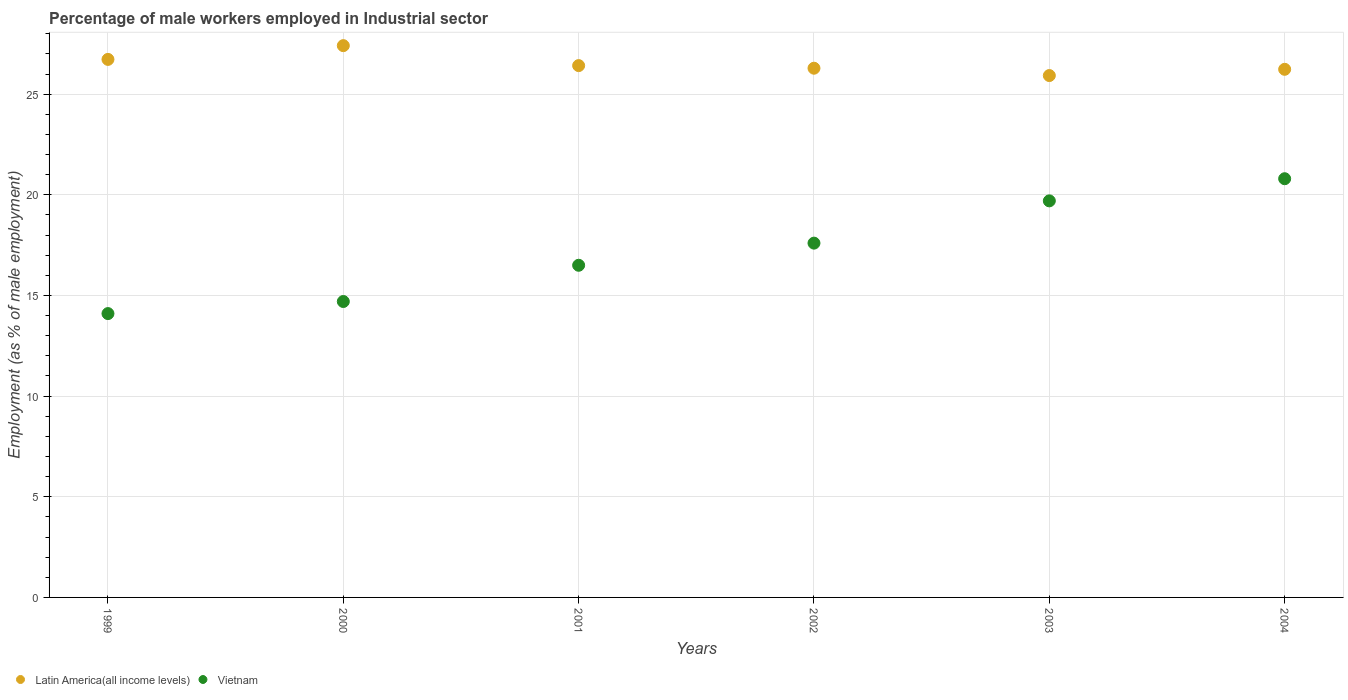How many different coloured dotlines are there?
Offer a terse response. 2. What is the percentage of male workers employed in Industrial sector in Latin America(all income levels) in 2002?
Your answer should be compact. 26.29. Across all years, what is the maximum percentage of male workers employed in Industrial sector in Latin America(all income levels)?
Give a very brief answer. 27.41. Across all years, what is the minimum percentage of male workers employed in Industrial sector in Vietnam?
Provide a succinct answer. 14.1. In which year was the percentage of male workers employed in Industrial sector in Latin America(all income levels) minimum?
Make the answer very short. 2003. What is the total percentage of male workers employed in Industrial sector in Latin America(all income levels) in the graph?
Make the answer very short. 159.01. What is the difference between the percentage of male workers employed in Industrial sector in Latin America(all income levels) in 1999 and that in 2003?
Offer a terse response. 0.8. What is the difference between the percentage of male workers employed in Industrial sector in Latin America(all income levels) in 2004 and the percentage of male workers employed in Industrial sector in Vietnam in 2003?
Keep it short and to the point. 6.53. What is the average percentage of male workers employed in Industrial sector in Vietnam per year?
Offer a very short reply. 17.23. In the year 1999, what is the difference between the percentage of male workers employed in Industrial sector in Latin America(all income levels) and percentage of male workers employed in Industrial sector in Vietnam?
Offer a very short reply. 12.63. What is the ratio of the percentage of male workers employed in Industrial sector in Latin America(all income levels) in 1999 to that in 2001?
Make the answer very short. 1.01. What is the difference between the highest and the second highest percentage of male workers employed in Industrial sector in Vietnam?
Your answer should be compact. 1.1. What is the difference between the highest and the lowest percentage of male workers employed in Industrial sector in Vietnam?
Give a very brief answer. 6.7. Is the percentage of male workers employed in Industrial sector in Latin America(all income levels) strictly less than the percentage of male workers employed in Industrial sector in Vietnam over the years?
Your answer should be very brief. No. How many dotlines are there?
Make the answer very short. 2. How many years are there in the graph?
Your response must be concise. 6. Are the values on the major ticks of Y-axis written in scientific E-notation?
Your answer should be very brief. No. Does the graph contain any zero values?
Ensure brevity in your answer.  No. Where does the legend appear in the graph?
Provide a short and direct response. Bottom left. How many legend labels are there?
Make the answer very short. 2. What is the title of the graph?
Your answer should be very brief. Percentage of male workers employed in Industrial sector. Does "Romania" appear as one of the legend labels in the graph?
Ensure brevity in your answer.  No. What is the label or title of the X-axis?
Your response must be concise. Years. What is the label or title of the Y-axis?
Offer a terse response. Employment (as % of male employment). What is the Employment (as % of male employment) of Latin America(all income levels) in 1999?
Ensure brevity in your answer.  26.73. What is the Employment (as % of male employment) of Vietnam in 1999?
Your answer should be very brief. 14.1. What is the Employment (as % of male employment) of Latin America(all income levels) in 2000?
Offer a very short reply. 27.41. What is the Employment (as % of male employment) in Vietnam in 2000?
Your answer should be compact. 14.7. What is the Employment (as % of male employment) in Latin America(all income levels) in 2001?
Offer a terse response. 26.42. What is the Employment (as % of male employment) in Vietnam in 2001?
Provide a succinct answer. 16.5. What is the Employment (as % of male employment) of Latin America(all income levels) in 2002?
Make the answer very short. 26.29. What is the Employment (as % of male employment) in Vietnam in 2002?
Offer a very short reply. 17.6. What is the Employment (as % of male employment) of Latin America(all income levels) in 2003?
Your answer should be compact. 25.92. What is the Employment (as % of male employment) in Vietnam in 2003?
Give a very brief answer. 19.7. What is the Employment (as % of male employment) of Latin America(all income levels) in 2004?
Offer a very short reply. 26.23. What is the Employment (as % of male employment) of Vietnam in 2004?
Provide a short and direct response. 20.8. Across all years, what is the maximum Employment (as % of male employment) in Latin America(all income levels)?
Provide a succinct answer. 27.41. Across all years, what is the maximum Employment (as % of male employment) of Vietnam?
Provide a short and direct response. 20.8. Across all years, what is the minimum Employment (as % of male employment) in Latin America(all income levels)?
Make the answer very short. 25.92. Across all years, what is the minimum Employment (as % of male employment) of Vietnam?
Your answer should be very brief. 14.1. What is the total Employment (as % of male employment) in Latin America(all income levels) in the graph?
Keep it short and to the point. 159.01. What is the total Employment (as % of male employment) of Vietnam in the graph?
Provide a succinct answer. 103.4. What is the difference between the Employment (as % of male employment) of Latin America(all income levels) in 1999 and that in 2000?
Provide a succinct answer. -0.68. What is the difference between the Employment (as % of male employment) in Vietnam in 1999 and that in 2000?
Your answer should be very brief. -0.6. What is the difference between the Employment (as % of male employment) in Latin America(all income levels) in 1999 and that in 2001?
Your answer should be compact. 0.31. What is the difference between the Employment (as % of male employment) in Vietnam in 1999 and that in 2001?
Provide a short and direct response. -2.4. What is the difference between the Employment (as % of male employment) in Latin America(all income levels) in 1999 and that in 2002?
Provide a succinct answer. 0.44. What is the difference between the Employment (as % of male employment) in Vietnam in 1999 and that in 2002?
Your answer should be very brief. -3.5. What is the difference between the Employment (as % of male employment) in Latin America(all income levels) in 1999 and that in 2003?
Offer a very short reply. 0.8. What is the difference between the Employment (as % of male employment) of Latin America(all income levels) in 1999 and that in 2004?
Make the answer very short. 0.49. What is the difference between the Employment (as % of male employment) of Vietnam in 2000 and that in 2001?
Ensure brevity in your answer.  -1.8. What is the difference between the Employment (as % of male employment) in Latin America(all income levels) in 2000 and that in 2002?
Provide a short and direct response. 1.12. What is the difference between the Employment (as % of male employment) of Vietnam in 2000 and that in 2002?
Keep it short and to the point. -2.9. What is the difference between the Employment (as % of male employment) of Latin America(all income levels) in 2000 and that in 2003?
Ensure brevity in your answer.  1.49. What is the difference between the Employment (as % of male employment) of Vietnam in 2000 and that in 2003?
Ensure brevity in your answer.  -5. What is the difference between the Employment (as % of male employment) in Latin America(all income levels) in 2000 and that in 2004?
Provide a short and direct response. 1.18. What is the difference between the Employment (as % of male employment) in Latin America(all income levels) in 2001 and that in 2002?
Offer a very short reply. 0.13. What is the difference between the Employment (as % of male employment) of Latin America(all income levels) in 2001 and that in 2003?
Offer a very short reply. 0.49. What is the difference between the Employment (as % of male employment) of Vietnam in 2001 and that in 2003?
Provide a short and direct response. -3.2. What is the difference between the Employment (as % of male employment) of Latin America(all income levels) in 2001 and that in 2004?
Keep it short and to the point. 0.18. What is the difference between the Employment (as % of male employment) in Vietnam in 2001 and that in 2004?
Provide a short and direct response. -4.3. What is the difference between the Employment (as % of male employment) in Latin America(all income levels) in 2002 and that in 2003?
Make the answer very short. 0.36. What is the difference between the Employment (as % of male employment) of Vietnam in 2002 and that in 2003?
Your answer should be very brief. -2.1. What is the difference between the Employment (as % of male employment) of Latin America(all income levels) in 2002 and that in 2004?
Make the answer very short. 0.05. What is the difference between the Employment (as % of male employment) of Latin America(all income levels) in 2003 and that in 2004?
Keep it short and to the point. -0.31. What is the difference between the Employment (as % of male employment) in Latin America(all income levels) in 1999 and the Employment (as % of male employment) in Vietnam in 2000?
Give a very brief answer. 12.03. What is the difference between the Employment (as % of male employment) of Latin America(all income levels) in 1999 and the Employment (as % of male employment) of Vietnam in 2001?
Your answer should be very brief. 10.23. What is the difference between the Employment (as % of male employment) in Latin America(all income levels) in 1999 and the Employment (as % of male employment) in Vietnam in 2002?
Provide a succinct answer. 9.13. What is the difference between the Employment (as % of male employment) of Latin America(all income levels) in 1999 and the Employment (as % of male employment) of Vietnam in 2003?
Ensure brevity in your answer.  7.03. What is the difference between the Employment (as % of male employment) of Latin America(all income levels) in 1999 and the Employment (as % of male employment) of Vietnam in 2004?
Ensure brevity in your answer.  5.93. What is the difference between the Employment (as % of male employment) of Latin America(all income levels) in 2000 and the Employment (as % of male employment) of Vietnam in 2001?
Offer a very short reply. 10.91. What is the difference between the Employment (as % of male employment) of Latin America(all income levels) in 2000 and the Employment (as % of male employment) of Vietnam in 2002?
Provide a succinct answer. 9.81. What is the difference between the Employment (as % of male employment) of Latin America(all income levels) in 2000 and the Employment (as % of male employment) of Vietnam in 2003?
Give a very brief answer. 7.71. What is the difference between the Employment (as % of male employment) in Latin America(all income levels) in 2000 and the Employment (as % of male employment) in Vietnam in 2004?
Offer a terse response. 6.61. What is the difference between the Employment (as % of male employment) of Latin America(all income levels) in 2001 and the Employment (as % of male employment) of Vietnam in 2002?
Give a very brief answer. 8.82. What is the difference between the Employment (as % of male employment) in Latin America(all income levels) in 2001 and the Employment (as % of male employment) in Vietnam in 2003?
Ensure brevity in your answer.  6.72. What is the difference between the Employment (as % of male employment) of Latin America(all income levels) in 2001 and the Employment (as % of male employment) of Vietnam in 2004?
Offer a very short reply. 5.62. What is the difference between the Employment (as % of male employment) in Latin America(all income levels) in 2002 and the Employment (as % of male employment) in Vietnam in 2003?
Make the answer very short. 6.59. What is the difference between the Employment (as % of male employment) in Latin America(all income levels) in 2002 and the Employment (as % of male employment) in Vietnam in 2004?
Make the answer very short. 5.49. What is the difference between the Employment (as % of male employment) of Latin America(all income levels) in 2003 and the Employment (as % of male employment) of Vietnam in 2004?
Your answer should be compact. 5.12. What is the average Employment (as % of male employment) of Latin America(all income levels) per year?
Give a very brief answer. 26.5. What is the average Employment (as % of male employment) in Vietnam per year?
Give a very brief answer. 17.23. In the year 1999, what is the difference between the Employment (as % of male employment) of Latin America(all income levels) and Employment (as % of male employment) of Vietnam?
Provide a succinct answer. 12.63. In the year 2000, what is the difference between the Employment (as % of male employment) in Latin America(all income levels) and Employment (as % of male employment) in Vietnam?
Offer a very short reply. 12.71. In the year 2001, what is the difference between the Employment (as % of male employment) in Latin America(all income levels) and Employment (as % of male employment) in Vietnam?
Your response must be concise. 9.92. In the year 2002, what is the difference between the Employment (as % of male employment) in Latin America(all income levels) and Employment (as % of male employment) in Vietnam?
Keep it short and to the point. 8.69. In the year 2003, what is the difference between the Employment (as % of male employment) in Latin America(all income levels) and Employment (as % of male employment) in Vietnam?
Ensure brevity in your answer.  6.22. In the year 2004, what is the difference between the Employment (as % of male employment) in Latin America(all income levels) and Employment (as % of male employment) in Vietnam?
Make the answer very short. 5.43. What is the ratio of the Employment (as % of male employment) in Latin America(all income levels) in 1999 to that in 2000?
Provide a succinct answer. 0.98. What is the ratio of the Employment (as % of male employment) in Vietnam in 1999 to that in 2000?
Provide a succinct answer. 0.96. What is the ratio of the Employment (as % of male employment) in Latin America(all income levels) in 1999 to that in 2001?
Ensure brevity in your answer.  1.01. What is the ratio of the Employment (as % of male employment) in Vietnam in 1999 to that in 2001?
Provide a succinct answer. 0.85. What is the ratio of the Employment (as % of male employment) in Latin America(all income levels) in 1999 to that in 2002?
Your answer should be very brief. 1.02. What is the ratio of the Employment (as % of male employment) of Vietnam in 1999 to that in 2002?
Ensure brevity in your answer.  0.8. What is the ratio of the Employment (as % of male employment) of Latin America(all income levels) in 1999 to that in 2003?
Your answer should be very brief. 1.03. What is the ratio of the Employment (as % of male employment) in Vietnam in 1999 to that in 2003?
Offer a terse response. 0.72. What is the ratio of the Employment (as % of male employment) in Latin America(all income levels) in 1999 to that in 2004?
Ensure brevity in your answer.  1.02. What is the ratio of the Employment (as % of male employment) in Vietnam in 1999 to that in 2004?
Make the answer very short. 0.68. What is the ratio of the Employment (as % of male employment) in Latin America(all income levels) in 2000 to that in 2001?
Provide a short and direct response. 1.04. What is the ratio of the Employment (as % of male employment) of Vietnam in 2000 to that in 2001?
Offer a terse response. 0.89. What is the ratio of the Employment (as % of male employment) of Latin America(all income levels) in 2000 to that in 2002?
Ensure brevity in your answer.  1.04. What is the ratio of the Employment (as % of male employment) in Vietnam in 2000 to that in 2002?
Your answer should be compact. 0.84. What is the ratio of the Employment (as % of male employment) in Latin America(all income levels) in 2000 to that in 2003?
Provide a short and direct response. 1.06. What is the ratio of the Employment (as % of male employment) in Vietnam in 2000 to that in 2003?
Make the answer very short. 0.75. What is the ratio of the Employment (as % of male employment) in Latin America(all income levels) in 2000 to that in 2004?
Provide a succinct answer. 1.04. What is the ratio of the Employment (as % of male employment) in Vietnam in 2000 to that in 2004?
Your response must be concise. 0.71. What is the ratio of the Employment (as % of male employment) of Vietnam in 2001 to that in 2002?
Keep it short and to the point. 0.94. What is the ratio of the Employment (as % of male employment) in Latin America(all income levels) in 2001 to that in 2003?
Provide a succinct answer. 1.02. What is the ratio of the Employment (as % of male employment) of Vietnam in 2001 to that in 2003?
Provide a short and direct response. 0.84. What is the ratio of the Employment (as % of male employment) of Latin America(all income levels) in 2001 to that in 2004?
Your answer should be compact. 1.01. What is the ratio of the Employment (as % of male employment) in Vietnam in 2001 to that in 2004?
Ensure brevity in your answer.  0.79. What is the ratio of the Employment (as % of male employment) of Latin America(all income levels) in 2002 to that in 2003?
Provide a succinct answer. 1.01. What is the ratio of the Employment (as % of male employment) in Vietnam in 2002 to that in 2003?
Give a very brief answer. 0.89. What is the ratio of the Employment (as % of male employment) of Vietnam in 2002 to that in 2004?
Make the answer very short. 0.85. What is the ratio of the Employment (as % of male employment) of Vietnam in 2003 to that in 2004?
Offer a terse response. 0.95. What is the difference between the highest and the second highest Employment (as % of male employment) of Latin America(all income levels)?
Offer a terse response. 0.68. What is the difference between the highest and the second highest Employment (as % of male employment) in Vietnam?
Make the answer very short. 1.1. What is the difference between the highest and the lowest Employment (as % of male employment) of Latin America(all income levels)?
Your answer should be compact. 1.49. 